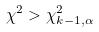<formula> <loc_0><loc_0><loc_500><loc_500>\chi ^ { 2 } > \chi _ { k - 1 , \alpha } ^ { 2 }</formula> 